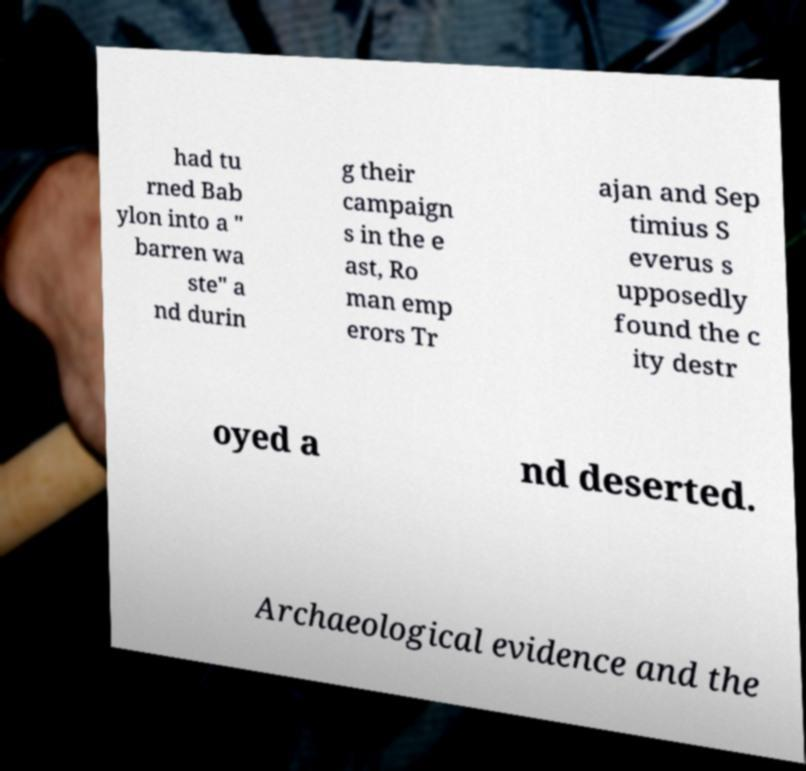Could you assist in decoding the text presented in this image and type it out clearly? had tu rned Bab ylon into a " barren wa ste" a nd durin g their campaign s in the e ast, Ro man emp erors Tr ajan and Sep timius S everus s upposedly found the c ity destr oyed a nd deserted. Archaeological evidence and the 